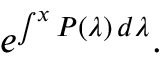Convert formula to latex. <formula><loc_0><loc_0><loc_500><loc_500>e ^ { \int ^ { x } P ( \lambda ) \, d \lambda } .</formula> 